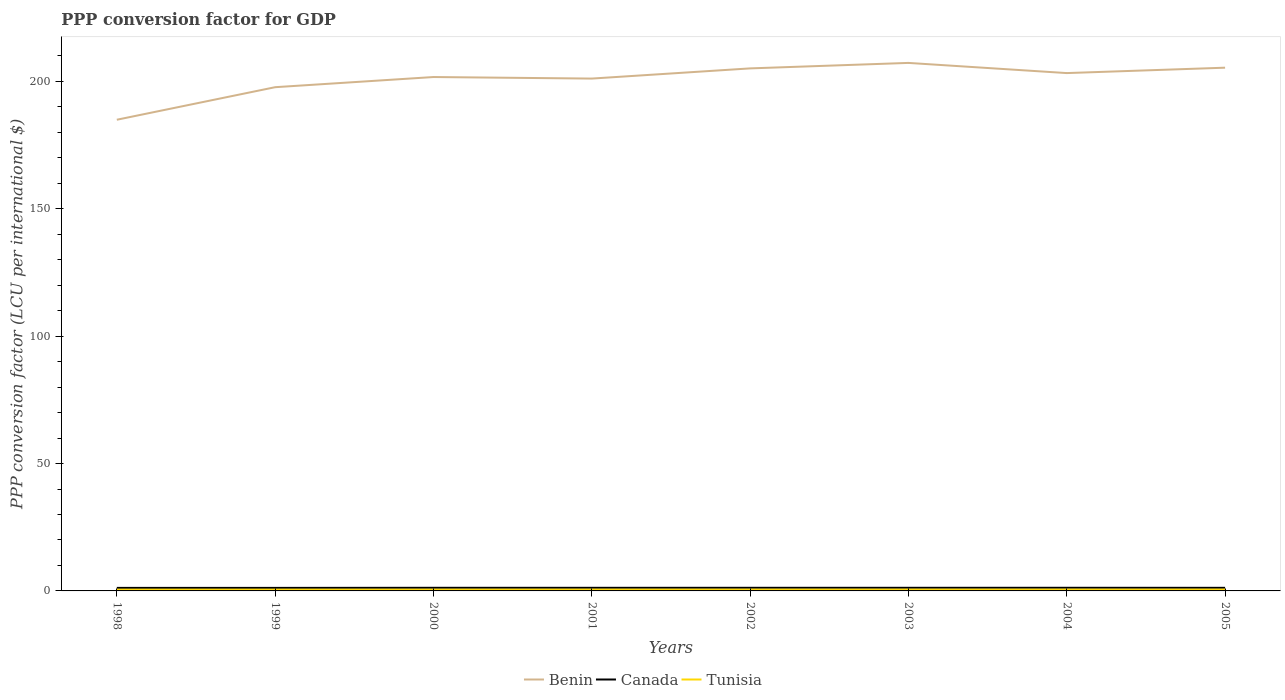How many different coloured lines are there?
Offer a very short reply. 3. Across all years, what is the maximum PPP conversion factor for GDP in Canada?
Keep it short and to the point. 1.19. What is the total PPP conversion factor for GDP in Canada in the graph?
Give a very brief answer. -0. What is the difference between the highest and the second highest PPP conversion factor for GDP in Canada?
Make the answer very short. 0.05. What is the difference between the highest and the lowest PPP conversion factor for GDP in Tunisia?
Keep it short and to the point. 5. How many lines are there?
Your answer should be compact. 3. How many years are there in the graph?
Your answer should be very brief. 8. What is the difference between two consecutive major ticks on the Y-axis?
Your response must be concise. 50. Are the values on the major ticks of Y-axis written in scientific E-notation?
Give a very brief answer. No. Does the graph contain grids?
Your answer should be very brief. No. Where does the legend appear in the graph?
Make the answer very short. Bottom center. How are the legend labels stacked?
Your answer should be very brief. Horizontal. What is the title of the graph?
Your response must be concise. PPP conversion factor for GDP. What is the label or title of the Y-axis?
Your answer should be very brief. PPP conversion factor (LCU per international $). What is the PPP conversion factor (LCU per international $) in Benin in 1998?
Your answer should be compact. 184.93. What is the PPP conversion factor (LCU per international $) in Canada in 1998?
Offer a very short reply. 1.19. What is the PPP conversion factor (LCU per international $) of Tunisia in 1998?
Your answer should be very brief. 0.49. What is the PPP conversion factor (LCU per international $) in Benin in 1999?
Keep it short and to the point. 197.71. What is the PPP conversion factor (LCU per international $) of Canada in 1999?
Make the answer very short. 1.19. What is the PPP conversion factor (LCU per international $) of Tunisia in 1999?
Offer a terse response. 0.5. What is the PPP conversion factor (LCU per international $) of Benin in 2000?
Provide a succinct answer. 201.69. What is the PPP conversion factor (LCU per international $) in Canada in 2000?
Provide a short and direct response. 1.23. What is the PPP conversion factor (LCU per international $) of Tunisia in 2000?
Your answer should be very brief. 0.5. What is the PPP conversion factor (LCU per international $) in Benin in 2001?
Offer a very short reply. 201.09. What is the PPP conversion factor (LCU per international $) of Canada in 2001?
Your answer should be very brief. 1.22. What is the PPP conversion factor (LCU per international $) in Tunisia in 2001?
Offer a very short reply. 0.51. What is the PPP conversion factor (LCU per international $) of Benin in 2002?
Ensure brevity in your answer.  205.09. What is the PPP conversion factor (LCU per international $) in Canada in 2002?
Ensure brevity in your answer.  1.23. What is the PPP conversion factor (LCU per international $) of Tunisia in 2002?
Your answer should be very brief. 0.52. What is the PPP conversion factor (LCU per international $) in Benin in 2003?
Give a very brief answer. 207.24. What is the PPP conversion factor (LCU per international $) of Canada in 2003?
Ensure brevity in your answer.  1.23. What is the PPP conversion factor (LCU per international $) in Tunisia in 2003?
Your answer should be very brief. 0.52. What is the PPP conversion factor (LCU per international $) in Benin in 2004?
Ensure brevity in your answer.  203.24. What is the PPP conversion factor (LCU per international $) in Canada in 2004?
Your answer should be very brief. 1.23. What is the PPP conversion factor (LCU per international $) of Tunisia in 2004?
Provide a succinct answer. 0.52. What is the PPP conversion factor (LCU per international $) in Benin in 2005?
Keep it short and to the point. 205.36. What is the PPP conversion factor (LCU per international $) in Canada in 2005?
Your answer should be compact. 1.21. What is the PPP conversion factor (LCU per international $) of Tunisia in 2005?
Provide a short and direct response. 0.53. Across all years, what is the maximum PPP conversion factor (LCU per international $) of Benin?
Keep it short and to the point. 207.24. Across all years, what is the maximum PPP conversion factor (LCU per international $) in Canada?
Your response must be concise. 1.23. Across all years, what is the maximum PPP conversion factor (LCU per international $) of Tunisia?
Ensure brevity in your answer.  0.53. Across all years, what is the minimum PPP conversion factor (LCU per international $) of Benin?
Your response must be concise. 184.93. Across all years, what is the minimum PPP conversion factor (LCU per international $) of Canada?
Make the answer very short. 1.19. Across all years, what is the minimum PPP conversion factor (LCU per international $) in Tunisia?
Your response must be concise. 0.49. What is the total PPP conversion factor (LCU per international $) in Benin in the graph?
Offer a very short reply. 1606.36. What is the total PPP conversion factor (LCU per international $) in Canada in the graph?
Offer a terse response. 9.73. What is the total PPP conversion factor (LCU per international $) of Tunisia in the graph?
Keep it short and to the point. 4.1. What is the difference between the PPP conversion factor (LCU per international $) in Benin in 1998 and that in 1999?
Offer a very short reply. -12.77. What is the difference between the PPP conversion factor (LCU per international $) of Canada in 1998 and that in 1999?
Provide a succinct answer. -0. What is the difference between the PPP conversion factor (LCU per international $) in Tunisia in 1998 and that in 1999?
Offer a very short reply. -0.01. What is the difference between the PPP conversion factor (LCU per international $) in Benin in 1998 and that in 2000?
Keep it short and to the point. -16.76. What is the difference between the PPP conversion factor (LCU per international $) in Canada in 1998 and that in 2000?
Give a very brief answer. -0.04. What is the difference between the PPP conversion factor (LCU per international $) of Tunisia in 1998 and that in 2000?
Your response must be concise. -0.01. What is the difference between the PPP conversion factor (LCU per international $) of Benin in 1998 and that in 2001?
Your response must be concise. -16.16. What is the difference between the PPP conversion factor (LCU per international $) of Canada in 1998 and that in 2001?
Keep it short and to the point. -0.03. What is the difference between the PPP conversion factor (LCU per international $) in Tunisia in 1998 and that in 2001?
Your answer should be compact. -0.02. What is the difference between the PPP conversion factor (LCU per international $) of Benin in 1998 and that in 2002?
Keep it short and to the point. -20.15. What is the difference between the PPP conversion factor (LCU per international $) of Canada in 1998 and that in 2002?
Offer a terse response. -0.04. What is the difference between the PPP conversion factor (LCU per international $) in Tunisia in 1998 and that in 2002?
Offer a very short reply. -0.03. What is the difference between the PPP conversion factor (LCU per international $) of Benin in 1998 and that in 2003?
Provide a short and direct response. -22.3. What is the difference between the PPP conversion factor (LCU per international $) of Canada in 1998 and that in 2003?
Make the answer very short. -0.04. What is the difference between the PPP conversion factor (LCU per international $) in Tunisia in 1998 and that in 2003?
Your answer should be compact. -0.03. What is the difference between the PPP conversion factor (LCU per international $) of Benin in 1998 and that in 2004?
Your response must be concise. -18.31. What is the difference between the PPP conversion factor (LCU per international $) in Canada in 1998 and that in 2004?
Offer a terse response. -0.05. What is the difference between the PPP conversion factor (LCU per international $) of Tunisia in 1998 and that in 2004?
Give a very brief answer. -0.03. What is the difference between the PPP conversion factor (LCU per international $) in Benin in 1998 and that in 2005?
Offer a very short reply. -20.43. What is the difference between the PPP conversion factor (LCU per international $) of Canada in 1998 and that in 2005?
Your response must be concise. -0.03. What is the difference between the PPP conversion factor (LCU per international $) in Tunisia in 1998 and that in 2005?
Your response must be concise. -0.04. What is the difference between the PPP conversion factor (LCU per international $) of Benin in 1999 and that in 2000?
Make the answer very short. -3.99. What is the difference between the PPP conversion factor (LCU per international $) in Canada in 1999 and that in 2000?
Offer a very short reply. -0.04. What is the difference between the PPP conversion factor (LCU per international $) of Tunisia in 1999 and that in 2000?
Your response must be concise. -0. What is the difference between the PPP conversion factor (LCU per international $) of Benin in 1999 and that in 2001?
Your response must be concise. -3.38. What is the difference between the PPP conversion factor (LCU per international $) of Canada in 1999 and that in 2001?
Your response must be concise. -0.03. What is the difference between the PPP conversion factor (LCU per international $) in Tunisia in 1999 and that in 2001?
Your response must be concise. -0.01. What is the difference between the PPP conversion factor (LCU per international $) in Benin in 1999 and that in 2002?
Your answer should be very brief. -7.38. What is the difference between the PPP conversion factor (LCU per international $) of Canada in 1999 and that in 2002?
Offer a very short reply. -0.04. What is the difference between the PPP conversion factor (LCU per international $) in Tunisia in 1999 and that in 2002?
Your answer should be very brief. -0.02. What is the difference between the PPP conversion factor (LCU per international $) in Benin in 1999 and that in 2003?
Your answer should be compact. -9.53. What is the difference between the PPP conversion factor (LCU per international $) in Canada in 1999 and that in 2003?
Offer a very short reply. -0.04. What is the difference between the PPP conversion factor (LCU per international $) of Tunisia in 1999 and that in 2003?
Your response must be concise. -0.02. What is the difference between the PPP conversion factor (LCU per international $) in Benin in 1999 and that in 2004?
Keep it short and to the point. -5.54. What is the difference between the PPP conversion factor (LCU per international $) in Canada in 1999 and that in 2004?
Make the answer very short. -0.04. What is the difference between the PPP conversion factor (LCU per international $) of Tunisia in 1999 and that in 2004?
Your response must be concise. -0.02. What is the difference between the PPP conversion factor (LCU per international $) of Benin in 1999 and that in 2005?
Provide a succinct answer. -7.66. What is the difference between the PPP conversion factor (LCU per international $) in Canada in 1999 and that in 2005?
Your response must be concise. -0.02. What is the difference between the PPP conversion factor (LCU per international $) of Tunisia in 1999 and that in 2005?
Keep it short and to the point. -0.03. What is the difference between the PPP conversion factor (LCU per international $) in Benin in 2000 and that in 2001?
Your answer should be compact. 0.61. What is the difference between the PPP conversion factor (LCU per international $) of Canada in 2000 and that in 2001?
Offer a very short reply. 0.01. What is the difference between the PPP conversion factor (LCU per international $) in Tunisia in 2000 and that in 2001?
Your response must be concise. -0.01. What is the difference between the PPP conversion factor (LCU per international $) of Benin in 2000 and that in 2002?
Offer a terse response. -3.39. What is the difference between the PPP conversion factor (LCU per international $) in Canada in 2000 and that in 2002?
Keep it short and to the point. -0. What is the difference between the PPP conversion factor (LCU per international $) in Tunisia in 2000 and that in 2002?
Your answer should be very brief. -0.01. What is the difference between the PPP conversion factor (LCU per international $) of Benin in 2000 and that in 2003?
Provide a short and direct response. -5.54. What is the difference between the PPP conversion factor (LCU per international $) in Canada in 2000 and that in 2003?
Offer a terse response. 0. What is the difference between the PPP conversion factor (LCU per international $) of Tunisia in 2000 and that in 2003?
Provide a succinct answer. -0.02. What is the difference between the PPP conversion factor (LCU per international $) of Benin in 2000 and that in 2004?
Keep it short and to the point. -1.55. What is the difference between the PPP conversion factor (LCU per international $) of Canada in 2000 and that in 2004?
Give a very brief answer. -0.01. What is the difference between the PPP conversion factor (LCU per international $) of Tunisia in 2000 and that in 2004?
Your answer should be compact. -0.02. What is the difference between the PPP conversion factor (LCU per international $) in Benin in 2000 and that in 2005?
Offer a terse response. -3.67. What is the difference between the PPP conversion factor (LCU per international $) of Canada in 2000 and that in 2005?
Offer a very short reply. 0.01. What is the difference between the PPP conversion factor (LCU per international $) in Tunisia in 2000 and that in 2005?
Offer a very short reply. -0.02. What is the difference between the PPP conversion factor (LCU per international $) in Benin in 2001 and that in 2002?
Give a very brief answer. -4. What is the difference between the PPP conversion factor (LCU per international $) of Canada in 2001 and that in 2002?
Your answer should be compact. -0.01. What is the difference between the PPP conversion factor (LCU per international $) in Tunisia in 2001 and that in 2002?
Your response must be concise. -0. What is the difference between the PPP conversion factor (LCU per international $) of Benin in 2001 and that in 2003?
Keep it short and to the point. -6.15. What is the difference between the PPP conversion factor (LCU per international $) of Canada in 2001 and that in 2003?
Provide a succinct answer. -0.01. What is the difference between the PPP conversion factor (LCU per international $) in Tunisia in 2001 and that in 2003?
Offer a very short reply. -0.01. What is the difference between the PPP conversion factor (LCU per international $) of Benin in 2001 and that in 2004?
Give a very brief answer. -2.16. What is the difference between the PPP conversion factor (LCU per international $) in Canada in 2001 and that in 2004?
Ensure brevity in your answer.  -0.01. What is the difference between the PPP conversion factor (LCU per international $) in Tunisia in 2001 and that in 2004?
Your answer should be compact. -0.01. What is the difference between the PPP conversion factor (LCU per international $) of Benin in 2001 and that in 2005?
Offer a very short reply. -4.27. What is the difference between the PPP conversion factor (LCU per international $) of Canada in 2001 and that in 2005?
Give a very brief answer. 0.01. What is the difference between the PPP conversion factor (LCU per international $) of Tunisia in 2001 and that in 2005?
Offer a very short reply. -0.02. What is the difference between the PPP conversion factor (LCU per international $) in Benin in 2002 and that in 2003?
Ensure brevity in your answer.  -2.15. What is the difference between the PPP conversion factor (LCU per international $) in Canada in 2002 and that in 2003?
Offer a terse response. 0. What is the difference between the PPP conversion factor (LCU per international $) of Tunisia in 2002 and that in 2003?
Offer a terse response. -0. What is the difference between the PPP conversion factor (LCU per international $) of Benin in 2002 and that in 2004?
Give a very brief answer. 1.84. What is the difference between the PPP conversion factor (LCU per international $) in Canada in 2002 and that in 2004?
Provide a succinct answer. -0. What is the difference between the PPP conversion factor (LCU per international $) in Tunisia in 2002 and that in 2004?
Provide a short and direct response. -0.01. What is the difference between the PPP conversion factor (LCU per international $) of Benin in 2002 and that in 2005?
Ensure brevity in your answer.  -0.28. What is the difference between the PPP conversion factor (LCU per international $) in Canada in 2002 and that in 2005?
Keep it short and to the point. 0.02. What is the difference between the PPP conversion factor (LCU per international $) in Tunisia in 2002 and that in 2005?
Give a very brief answer. -0.01. What is the difference between the PPP conversion factor (LCU per international $) of Benin in 2003 and that in 2004?
Give a very brief answer. 3.99. What is the difference between the PPP conversion factor (LCU per international $) of Canada in 2003 and that in 2004?
Ensure brevity in your answer.  -0.01. What is the difference between the PPP conversion factor (LCU per international $) in Tunisia in 2003 and that in 2004?
Provide a succinct answer. -0. What is the difference between the PPP conversion factor (LCU per international $) of Benin in 2003 and that in 2005?
Offer a terse response. 1.87. What is the difference between the PPP conversion factor (LCU per international $) in Canada in 2003 and that in 2005?
Give a very brief answer. 0.01. What is the difference between the PPP conversion factor (LCU per international $) in Tunisia in 2003 and that in 2005?
Give a very brief answer. -0.01. What is the difference between the PPP conversion factor (LCU per international $) of Benin in 2004 and that in 2005?
Provide a short and direct response. -2.12. What is the difference between the PPP conversion factor (LCU per international $) of Canada in 2004 and that in 2005?
Provide a succinct answer. 0.02. What is the difference between the PPP conversion factor (LCU per international $) in Tunisia in 2004 and that in 2005?
Provide a short and direct response. -0. What is the difference between the PPP conversion factor (LCU per international $) in Benin in 1998 and the PPP conversion factor (LCU per international $) in Canada in 1999?
Give a very brief answer. 183.74. What is the difference between the PPP conversion factor (LCU per international $) of Benin in 1998 and the PPP conversion factor (LCU per international $) of Tunisia in 1999?
Keep it short and to the point. 184.43. What is the difference between the PPP conversion factor (LCU per international $) in Canada in 1998 and the PPP conversion factor (LCU per international $) in Tunisia in 1999?
Provide a short and direct response. 0.69. What is the difference between the PPP conversion factor (LCU per international $) in Benin in 1998 and the PPP conversion factor (LCU per international $) in Canada in 2000?
Your response must be concise. 183.71. What is the difference between the PPP conversion factor (LCU per international $) of Benin in 1998 and the PPP conversion factor (LCU per international $) of Tunisia in 2000?
Make the answer very short. 184.43. What is the difference between the PPP conversion factor (LCU per international $) of Canada in 1998 and the PPP conversion factor (LCU per international $) of Tunisia in 2000?
Offer a terse response. 0.68. What is the difference between the PPP conversion factor (LCU per international $) of Benin in 1998 and the PPP conversion factor (LCU per international $) of Canada in 2001?
Keep it short and to the point. 183.71. What is the difference between the PPP conversion factor (LCU per international $) of Benin in 1998 and the PPP conversion factor (LCU per international $) of Tunisia in 2001?
Your answer should be compact. 184.42. What is the difference between the PPP conversion factor (LCU per international $) in Canada in 1998 and the PPP conversion factor (LCU per international $) in Tunisia in 2001?
Provide a succinct answer. 0.67. What is the difference between the PPP conversion factor (LCU per international $) in Benin in 1998 and the PPP conversion factor (LCU per international $) in Canada in 2002?
Provide a short and direct response. 183.7. What is the difference between the PPP conversion factor (LCU per international $) in Benin in 1998 and the PPP conversion factor (LCU per international $) in Tunisia in 2002?
Provide a succinct answer. 184.42. What is the difference between the PPP conversion factor (LCU per international $) in Canada in 1998 and the PPP conversion factor (LCU per international $) in Tunisia in 2002?
Provide a succinct answer. 0.67. What is the difference between the PPP conversion factor (LCU per international $) of Benin in 1998 and the PPP conversion factor (LCU per international $) of Canada in 2003?
Provide a short and direct response. 183.71. What is the difference between the PPP conversion factor (LCU per international $) in Benin in 1998 and the PPP conversion factor (LCU per international $) in Tunisia in 2003?
Ensure brevity in your answer.  184.41. What is the difference between the PPP conversion factor (LCU per international $) in Canada in 1998 and the PPP conversion factor (LCU per international $) in Tunisia in 2003?
Ensure brevity in your answer.  0.67. What is the difference between the PPP conversion factor (LCU per international $) in Benin in 1998 and the PPP conversion factor (LCU per international $) in Canada in 2004?
Your answer should be very brief. 183.7. What is the difference between the PPP conversion factor (LCU per international $) of Benin in 1998 and the PPP conversion factor (LCU per international $) of Tunisia in 2004?
Offer a very short reply. 184.41. What is the difference between the PPP conversion factor (LCU per international $) in Canada in 1998 and the PPP conversion factor (LCU per international $) in Tunisia in 2004?
Keep it short and to the point. 0.66. What is the difference between the PPP conversion factor (LCU per international $) in Benin in 1998 and the PPP conversion factor (LCU per international $) in Canada in 2005?
Give a very brief answer. 183.72. What is the difference between the PPP conversion factor (LCU per international $) of Benin in 1998 and the PPP conversion factor (LCU per international $) of Tunisia in 2005?
Provide a succinct answer. 184.41. What is the difference between the PPP conversion factor (LCU per international $) in Canada in 1998 and the PPP conversion factor (LCU per international $) in Tunisia in 2005?
Offer a very short reply. 0.66. What is the difference between the PPP conversion factor (LCU per international $) in Benin in 1999 and the PPP conversion factor (LCU per international $) in Canada in 2000?
Your answer should be compact. 196.48. What is the difference between the PPP conversion factor (LCU per international $) in Benin in 1999 and the PPP conversion factor (LCU per international $) in Tunisia in 2000?
Your answer should be very brief. 197.2. What is the difference between the PPP conversion factor (LCU per international $) in Canada in 1999 and the PPP conversion factor (LCU per international $) in Tunisia in 2000?
Keep it short and to the point. 0.69. What is the difference between the PPP conversion factor (LCU per international $) in Benin in 1999 and the PPP conversion factor (LCU per international $) in Canada in 2001?
Provide a short and direct response. 196.49. What is the difference between the PPP conversion factor (LCU per international $) of Benin in 1999 and the PPP conversion factor (LCU per international $) of Tunisia in 2001?
Provide a short and direct response. 197.19. What is the difference between the PPP conversion factor (LCU per international $) of Canada in 1999 and the PPP conversion factor (LCU per international $) of Tunisia in 2001?
Give a very brief answer. 0.68. What is the difference between the PPP conversion factor (LCU per international $) of Benin in 1999 and the PPP conversion factor (LCU per international $) of Canada in 2002?
Ensure brevity in your answer.  196.48. What is the difference between the PPP conversion factor (LCU per international $) of Benin in 1999 and the PPP conversion factor (LCU per international $) of Tunisia in 2002?
Provide a succinct answer. 197.19. What is the difference between the PPP conversion factor (LCU per international $) of Canada in 1999 and the PPP conversion factor (LCU per international $) of Tunisia in 2002?
Give a very brief answer. 0.67. What is the difference between the PPP conversion factor (LCU per international $) of Benin in 1999 and the PPP conversion factor (LCU per international $) of Canada in 2003?
Offer a terse response. 196.48. What is the difference between the PPP conversion factor (LCU per international $) of Benin in 1999 and the PPP conversion factor (LCU per international $) of Tunisia in 2003?
Make the answer very short. 197.19. What is the difference between the PPP conversion factor (LCU per international $) of Canada in 1999 and the PPP conversion factor (LCU per international $) of Tunisia in 2003?
Ensure brevity in your answer.  0.67. What is the difference between the PPP conversion factor (LCU per international $) in Benin in 1999 and the PPP conversion factor (LCU per international $) in Canada in 2004?
Provide a short and direct response. 196.47. What is the difference between the PPP conversion factor (LCU per international $) of Benin in 1999 and the PPP conversion factor (LCU per international $) of Tunisia in 2004?
Your answer should be very brief. 197.18. What is the difference between the PPP conversion factor (LCU per international $) in Canada in 1999 and the PPP conversion factor (LCU per international $) in Tunisia in 2004?
Give a very brief answer. 0.67. What is the difference between the PPP conversion factor (LCU per international $) in Benin in 1999 and the PPP conversion factor (LCU per international $) in Canada in 2005?
Provide a short and direct response. 196.49. What is the difference between the PPP conversion factor (LCU per international $) in Benin in 1999 and the PPP conversion factor (LCU per international $) in Tunisia in 2005?
Your response must be concise. 197.18. What is the difference between the PPP conversion factor (LCU per international $) in Canada in 1999 and the PPP conversion factor (LCU per international $) in Tunisia in 2005?
Offer a very short reply. 0.66. What is the difference between the PPP conversion factor (LCU per international $) in Benin in 2000 and the PPP conversion factor (LCU per international $) in Canada in 2001?
Give a very brief answer. 200.47. What is the difference between the PPP conversion factor (LCU per international $) in Benin in 2000 and the PPP conversion factor (LCU per international $) in Tunisia in 2001?
Provide a succinct answer. 201.18. What is the difference between the PPP conversion factor (LCU per international $) of Canada in 2000 and the PPP conversion factor (LCU per international $) of Tunisia in 2001?
Provide a short and direct response. 0.71. What is the difference between the PPP conversion factor (LCU per international $) of Benin in 2000 and the PPP conversion factor (LCU per international $) of Canada in 2002?
Ensure brevity in your answer.  200.47. What is the difference between the PPP conversion factor (LCU per international $) of Benin in 2000 and the PPP conversion factor (LCU per international $) of Tunisia in 2002?
Your answer should be compact. 201.18. What is the difference between the PPP conversion factor (LCU per international $) of Canada in 2000 and the PPP conversion factor (LCU per international $) of Tunisia in 2002?
Your response must be concise. 0.71. What is the difference between the PPP conversion factor (LCU per international $) in Benin in 2000 and the PPP conversion factor (LCU per international $) in Canada in 2003?
Ensure brevity in your answer.  200.47. What is the difference between the PPP conversion factor (LCU per international $) of Benin in 2000 and the PPP conversion factor (LCU per international $) of Tunisia in 2003?
Your answer should be very brief. 201.17. What is the difference between the PPP conversion factor (LCU per international $) in Canada in 2000 and the PPP conversion factor (LCU per international $) in Tunisia in 2003?
Provide a succinct answer. 0.71. What is the difference between the PPP conversion factor (LCU per international $) in Benin in 2000 and the PPP conversion factor (LCU per international $) in Canada in 2004?
Make the answer very short. 200.46. What is the difference between the PPP conversion factor (LCU per international $) in Benin in 2000 and the PPP conversion factor (LCU per international $) in Tunisia in 2004?
Make the answer very short. 201.17. What is the difference between the PPP conversion factor (LCU per international $) of Canada in 2000 and the PPP conversion factor (LCU per international $) of Tunisia in 2004?
Your answer should be very brief. 0.7. What is the difference between the PPP conversion factor (LCU per international $) of Benin in 2000 and the PPP conversion factor (LCU per international $) of Canada in 2005?
Your answer should be compact. 200.48. What is the difference between the PPP conversion factor (LCU per international $) in Benin in 2000 and the PPP conversion factor (LCU per international $) in Tunisia in 2005?
Provide a succinct answer. 201.17. What is the difference between the PPP conversion factor (LCU per international $) in Canada in 2000 and the PPP conversion factor (LCU per international $) in Tunisia in 2005?
Offer a very short reply. 0.7. What is the difference between the PPP conversion factor (LCU per international $) of Benin in 2001 and the PPP conversion factor (LCU per international $) of Canada in 2002?
Provide a succinct answer. 199.86. What is the difference between the PPP conversion factor (LCU per international $) in Benin in 2001 and the PPP conversion factor (LCU per international $) in Tunisia in 2002?
Provide a succinct answer. 200.57. What is the difference between the PPP conversion factor (LCU per international $) of Canada in 2001 and the PPP conversion factor (LCU per international $) of Tunisia in 2002?
Keep it short and to the point. 0.7. What is the difference between the PPP conversion factor (LCU per international $) of Benin in 2001 and the PPP conversion factor (LCU per international $) of Canada in 2003?
Give a very brief answer. 199.86. What is the difference between the PPP conversion factor (LCU per international $) in Benin in 2001 and the PPP conversion factor (LCU per international $) in Tunisia in 2003?
Make the answer very short. 200.57. What is the difference between the PPP conversion factor (LCU per international $) of Canada in 2001 and the PPP conversion factor (LCU per international $) of Tunisia in 2003?
Ensure brevity in your answer.  0.7. What is the difference between the PPP conversion factor (LCU per international $) in Benin in 2001 and the PPP conversion factor (LCU per international $) in Canada in 2004?
Make the answer very short. 199.86. What is the difference between the PPP conversion factor (LCU per international $) of Benin in 2001 and the PPP conversion factor (LCU per international $) of Tunisia in 2004?
Provide a succinct answer. 200.57. What is the difference between the PPP conversion factor (LCU per international $) of Canada in 2001 and the PPP conversion factor (LCU per international $) of Tunisia in 2004?
Keep it short and to the point. 0.7. What is the difference between the PPP conversion factor (LCU per international $) of Benin in 2001 and the PPP conversion factor (LCU per international $) of Canada in 2005?
Your answer should be very brief. 199.88. What is the difference between the PPP conversion factor (LCU per international $) of Benin in 2001 and the PPP conversion factor (LCU per international $) of Tunisia in 2005?
Give a very brief answer. 200.56. What is the difference between the PPP conversion factor (LCU per international $) in Canada in 2001 and the PPP conversion factor (LCU per international $) in Tunisia in 2005?
Offer a very short reply. 0.69. What is the difference between the PPP conversion factor (LCU per international $) in Benin in 2002 and the PPP conversion factor (LCU per international $) in Canada in 2003?
Make the answer very short. 203.86. What is the difference between the PPP conversion factor (LCU per international $) in Benin in 2002 and the PPP conversion factor (LCU per international $) in Tunisia in 2003?
Make the answer very short. 204.57. What is the difference between the PPP conversion factor (LCU per international $) in Canada in 2002 and the PPP conversion factor (LCU per international $) in Tunisia in 2003?
Give a very brief answer. 0.71. What is the difference between the PPP conversion factor (LCU per international $) of Benin in 2002 and the PPP conversion factor (LCU per international $) of Canada in 2004?
Provide a succinct answer. 203.85. What is the difference between the PPP conversion factor (LCU per international $) of Benin in 2002 and the PPP conversion factor (LCU per international $) of Tunisia in 2004?
Make the answer very short. 204.56. What is the difference between the PPP conversion factor (LCU per international $) in Canada in 2002 and the PPP conversion factor (LCU per international $) in Tunisia in 2004?
Your answer should be compact. 0.71. What is the difference between the PPP conversion factor (LCU per international $) in Benin in 2002 and the PPP conversion factor (LCU per international $) in Canada in 2005?
Offer a terse response. 203.87. What is the difference between the PPP conversion factor (LCU per international $) of Benin in 2002 and the PPP conversion factor (LCU per international $) of Tunisia in 2005?
Provide a short and direct response. 204.56. What is the difference between the PPP conversion factor (LCU per international $) of Canada in 2002 and the PPP conversion factor (LCU per international $) of Tunisia in 2005?
Keep it short and to the point. 0.7. What is the difference between the PPP conversion factor (LCU per international $) in Benin in 2003 and the PPP conversion factor (LCU per international $) in Canada in 2004?
Offer a very short reply. 206. What is the difference between the PPP conversion factor (LCU per international $) in Benin in 2003 and the PPP conversion factor (LCU per international $) in Tunisia in 2004?
Offer a terse response. 206.71. What is the difference between the PPP conversion factor (LCU per international $) of Canada in 2003 and the PPP conversion factor (LCU per international $) of Tunisia in 2004?
Provide a short and direct response. 0.7. What is the difference between the PPP conversion factor (LCU per international $) in Benin in 2003 and the PPP conversion factor (LCU per international $) in Canada in 2005?
Your answer should be compact. 206.02. What is the difference between the PPP conversion factor (LCU per international $) in Benin in 2003 and the PPP conversion factor (LCU per international $) in Tunisia in 2005?
Provide a succinct answer. 206.71. What is the difference between the PPP conversion factor (LCU per international $) of Canada in 2003 and the PPP conversion factor (LCU per international $) of Tunisia in 2005?
Offer a very short reply. 0.7. What is the difference between the PPP conversion factor (LCU per international $) of Benin in 2004 and the PPP conversion factor (LCU per international $) of Canada in 2005?
Your answer should be compact. 202.03. What is the difference between the PPP conversion factor (LCU per international $) in Benin in 2004 and the PPP conversion factor (LCU per international $) in Tunisia in 2005?
Give a very brief answer. 202.72. What is the difference between the PPP conversion factor (LCU per international $) in Canada in 2004 and the PPP conversion factor (LCU per international $) in Tunisia in 2005?
Your answer should be compact. 0.7. What is the average PPP conversion factor (LCU per international $) in Benin per year?
Your answer should be compact. 200.79. What is the average PPP conversion factor (LCU per international $) in Canada per year?
Your answer should be compact. 1.22. What is the average PPP conversion factor (LCU per international $) in Tunisia per year?
Your answer should be compact. 0.51. In the year 1998, what is the difference between the PPP conversion factor (LCU per international $) of Benin and PPP conversion factor (LCU per international $) of Canada?
Give a very brief answer. 183.75. In the year 1998, what is the difference between the PPP conversion factor (LCU per international $) in Benin and PPP conversion factor (LCU per international $) in Tunisia?
Your answer should be compact. 184.44. In the year 1998, what is the difference between the PPP conversion factor (LCU per international $) in Canada and PPP conversion factor (LCU per international $) in Tunisia?
Your answer should be very brief. 0.7. In the year 1999, what is the difference between the PPP conversion factor (LCU per international $) in Benin and PPP conversion factor (LCU per international $) in Canada?
Your answer should be compact. 196.52. In the year 1999, what is the difference between the PPP conversion factor (LCU per international $) in Benin and PPP conversion factor (LCU per international $) in Tunisia?
Provide a succinct answer. 197.21. In the year 1999, what is the difference between the PPP conversion factor (LCU per international $) in Canada and PPP conversion factor (LCU per international $) in Tunisia?
Offer a terse response. 0.69. In the year 2000, what is the difference between the PPP conversion factor (LCU per international $) of Benin and PPP conversion factor (LCU per international $) of Canada?
Offer a very short reply. 200.47. In the year 2000, what is the difference between the PPP conversion factor (LCU per international $) of Benin and PPP conversion factor (LCU per international $) of Tunisia?
Your answer should be compact. 201.19. In the year 2000, what is the difference between the PPP conversion factor (LCU per international $) of Canada and PPP conversion factor (LCU per international $) of Tunisia?
Offer a very short reply. 0.72. In the year 2001, what is the difference between the PPP conversion factor (LCU per international $) of Benin and PPP conversion factor (LCU per international $) of Canada?
Keep it short and to the point. 199.87. In the year 2001, what is the difference between the PPP conversion factor (LCU per international $) of Benin and PPP conversion factor (LCU per international $) of Tunisia?
Your answer should be very brief. 200.58. In the year 2001, what is the difference between the PPP conversion factor (LCU per international $) in Canada and PPP conversion factor (LCU per international $) in Tunisia?
Your answer should be very brief. 0.71. In the year 2002, what is the difference between the PPP conversion factor (LCU per international $) of Benin and PPP conversion factor (LCU per international $) of Canada?
Your answer should be compact. 203.86. In the year 2002, what is the difference between the PPP conversion factor (LCU per international $) of Benin and PPP conversion factor (LCU per international $) of Tunisia?
Offer a terse response. 204.57. In the year 2002, what is the difference between the PPP conversion factor (LCU per international $) of Canada and PPP conversion factor (LCU per international $) of Tunisia?
Ensure brevity in your answer.  0.71. In the year 2003, what is the difference between the PPP conversion factor (LCU per international $) in Benin and PPP conversion factor (LCU per international $) in Canada?
Provide a short and direct response. 206.01. In the year 2003, what is the difference between the PPP conversion factor (LCU per international $) of Benin and PPP conversion factor (LCU per international $) of Tunisia?
Provide a short and direct response. 206.72. In the year 2003, what is the difference between the PPP conversion factor (LCU per international $) in Canada and PPP conversion factor (LCU per international $) in Tunisia?
Your answer should be compact. 0.71. In the year 2004, what is the difference between the PPP conversion factor (LCU per international $) in Benin and PPP conversion factor (LCU per international $) in Canada?
Make the answer very short. 202.01. In the year 2004, what is the difference between the PPP conversion factor (LCU per international $) in Benin and PPP conversion factor (LCU per international $) in Tunisia?
Make the answer very short. 202.72. In the year 2004, what is the difference between the PPP conversion factor (LCU per international $) in Canada and PPP conversion factor (LCU per international $) in Tunisia?
Make the answer very short. 0.71. In the year 2005, what is the difference between the PPP conversion factor (LCU per international $) of Benin and PPP conversion factor (LCU per international $) of Canada?
Give a very brief answer. 204.15. In the year 2005, what is the difference between the PPP conversion factor (LCU per international $) of Benin and PPP conversion factor (LCU per international $) of Tunisia?
Keep it short and to the point. 204.84. In the year 2005, what is the difference between the PPP conversion factor (LCU per international $) in Canada and PPP conversion factor (LCU per international $) in Tunisia?
Provide a short and direct response. 0.69. What is the ratio of the PPP conversion factor (LCU per international $) in Benin in 1998 to that in 1999?
Your answer should be very brief. 0.94. What is the ratio of the PPP conversion factor (LCU per international $) in Tunisia in 1998 to that in 1999?
Ensure brevity in your answer.  0.98. What is the ratio of the PPP conversion factor (LCU per international $) in Benin in 1998 to that in 2000?
Give a very brief answer. 0.92. What is the ratio of the PPP conversion factor (LCU per international $) in Canada in 1998 to that in 2000?
Make the answer very short. 0.97. What is the ratio of the PPP conversion factor (LCU per international $) in Tunisia in 1998 to that in 2000?
Provide a succinct answer. 0.97. What is the ratio of the PPP conversion factor (LCU per international $) of Benin in 1998 to that in 2001?
Keep it short and to the point. 0.92. What is the ratio of the PPP conversion factor (LCU per international $) of Canada in 1998 to that in 2001?
Keep it short and to the point. 0.97. What is the ratio of the PPP conversion factor (LCU per international $) in Tunisia in 1998 to that in 2001?
Ensure brevity in your answer.  0.96. What is the ratio of the PPP conversion factor (LCU per international $) of Benin in 1998 to that in 2002?
Make the answer very short. 0.9. What is the ratio of the PPP conversion factor (LCU per international $) of Canada in 1998 to that in 2002?
Offer a terse response. 0.97. What is the ratio of the PPP conversion factor (LCU per international $) of Tunisia in 1998 to that in 2002?
Ensure brevity in your answer.  0.95. What is the ratio of the PPP conversion factor (LCU per international $) in Benin in 1998 to that in 2003?
Offer a very short reply. 0.89. What is the ratio of the PPP conversion factor (LCU per international $) in Canada in 1998 to that in 2003?
Make the answer very short. 0.97. What is the ratio of the PPP conversion factor (LCU per international $) in Tunisia in 1998 to that in 2003?
Offer a terse response. 0.94. What is the ratio of the PPP conversion factor (LCU per international $) in Benin in 1998 to that in 2004?
Provide a succinct answer. 0.91. What is the ratio of the PPP conversion factor (LCU per international $) of Canada in 1998 to that in 2004?
Your answer should be very brief. 0.96. What is the ratio of the PPP conversion factor (LCU per international $) in Tunisia in 1998 to that in 2004?
Offer a very short reply. 0.94. What is the ratio of the PPP conversion factor (LCU per international $) of Benin in 1998 to that in 2005?
Your answer should be very brief. 0.9. What is the ratio of the PPP conversion factor (LCU per international $) of Canada in 1998 to that in 2005?
Your response must be concise. 0.98. What is the ratio of the PPP conversion factor (LCU per international $) of Tunisia in 1998 to that in 2005?
Offer a terse response. 0.93. What is the ratio of the PPP conversion factor (LCU per international $) of Benin in 1999 to that in 2000?
Provide a short and direct response. 0.98. What is the ratio of the PPP conversion factor (LCU per international $) in Canada in 1999 to that in 2000?
Offer a very short reply. 0.97. What is the ratio of the PPP conversion factor (LCU per international $) of Tunisia in 1999 to that in 2000?
Provide a short and direct response. 0.99. What is the ratio of the PPP conversion factor (LCU per international $) of Benin in 1999 to that in 2001?
Offer a terse response. 0.98. What is the ratio of the PPP conversion factor (LCU per international $) of Canada in 1999 to that in 2001?
Keep it short and to the point. 0.98. What is the ratio of the PPP conversion factor (LCU per international $) of Tunisia in 1999 to that in 2001?
Your answer should be very brief. 0.97. What is the ratio of the PPP conversion factor (LCU per international $) in Benin in 1999 to that in 2002?
Offer a terse response. 0.96. What is the ratio of the PPP conversion factor (LCU per international $) of Canada in 1999 to that in 2002?
Ensure brevity in your answer.  0.97. What is the ratio of the PPP conversion factor (LCU per international $) in Tunisia in 1999 to that in 2002?
Provide a succinct answer. 0.97. What is the ratio of the PPP conversion factor (LCU per international $) in Benin in 1999 to that in 2003?
Ensure brevity in your answer.  0.95. What is the ratio of the PPP conversion factor (LCU per international $) of Benin in 1999 to that in 2004?
Give a very brief answer. 0.97. What is the ratio of the PPP conversion factor (LCU per international $) in Tunisia in 1999 to that in 2004?
Offer a very short reply. 0.96. What is the ratio of the PPP conversion factor (LCU per international $) of Benin in 1999 to that in 2005?
Keep it short and to the point. 0.96. What is the ratio of the PPP conversion factor (LCU per international $) of Canada in 1999 to that in 2005?
Provide a short and direct response. 0.98. What is the ratio of the PPP conversion factor (LCU per international $) in Tunisia in 1999 to that in 2005?
Make the answer very short. 0.95. What is the ratio of the PPP conversion factor (LCU per international $) of Tunisia in 2000 to that in 2001?
Make the answer very short. 0.98. What is the ratio of the PPP conversion factor (LCU per international $) of Benin in 2000 to that in 2002?
Your response must be concise. 0.98. What is the ratio of the PPP conversion factor (LCU per international $) in Canada in 2000 to that in 2002?
Your answer should be compact. 1. What is the ratio of the PPP conversion factor (LCU per international $) in Tunisia in 2000 to that in 2002?
Ensure brevity in your answer.  0.98. What is the ratio of the PPP conversion factor (LCU per international $) in Benin in 2000 to that in 2003?
Keep it short and to the point. 0.97. What is the ratio of the PPP conversion factor (LCU per international $) of Canada in 2000 to that in 2003?
Your answer should be compact. 1. What is the ratio of the PPP conversion factor (LCU per international $) in Tunisia in 2000 to that in 2003?
Make the answer very short. 0.97. What is the ratio of the PPP conversion factor (LCU per international $) of Benin in 2000 to that in 2004?
Offer a very short reply. 0.99. What is the ratio of the PPP conversion factor (LCU per international $) of Canada in 2000 to that in 2004?
Your response must be concise. 1. What is the ratio of the PPP conversion factor (LCU per international $) in Tunisia in 2000 to that in 2004?
Your answer should be very brief. 0.96. What is the ratio of the PPP conversion factor (LCU per international $) in Benin in 2000 to that in 2005?
Keep it short and to the point. 0.98. What is the ratio of the PPP conversion factor (LCU per international $) of Canada in 2000 to that in 2005?
Make the answer very short. 1.01. What is the ratio of the PPP conversion factor (LCU per international $) in Tunisia in 2000 to that in 2005?
Your response must be concise. 0.96. What is the ratio of the PPP conversion factor (LCU per international $) in Benin in 2001 to that in 2002?
Your answer should be compact. 0.98. What is the ratio of the PPP conversion factor (LCU per international $) in Benin in 2001 to that in 2003?
Your response must be concise. 0.97. What is the ratio of the PPP conversion factor (LCU per international $) of Canada in 2001 to that in 2003?
Provide a succinct answer. 0.99. What is the ratio of the PPP conversion factor (LCU per international $) of Canada in 2001 to that in 2004?
Give a very brief answer. 0.99. What is the ratio of the PPP conversion factor (LCU per international $) of Tunisia in 2001 to that in 2004?
Your answer should be very brief. 0.98. What is the ratio of the PPP conversion factor (LCU per international $) in Benin in 2001 to that in 2005?
Offer a terse response. 0.98. What is the ratio of the PPP conversion factor (LCU per international $) in Canada in 2001 to that in 2005?
Provide a short and direct response. 1. What is the ratio of the PPP conversion factor (LCU per international $) in Tunisia in 2001 to that in 2005?
Provide a short and direct response. 0.97. What is the ratio of the PPP conversion factor (LCU per international $) in Benin in 2002 to that in 2004?
Keep it short and to the point. 1.01. What is the ratio of the PPP conversion factor (LCU per international $) of Tunisia in 2002 to that in 2004?
Your answer should be very brief. 0.99. What is the ratio of the PPP conversion factor (LCU per international $) in Canada in 2002 to that in 2005?
Your answer should be very brief. 1.01. What is the ratio of the PPP conversion factor (LCU per international $) in Tunisia in 2002 to that in 2005?
Offer a very short reply. 0.98. What is the ratio of the PPP conversion factor (LCU per international $) in Benin in 2003 to that in 2004?
Offer a terse response. 1.02. What is the ratio of the PPP conversion factor (LCU per international $) in Canada in 2003 to that in 2004?
Offer a terse response. 0.99. What is the ratio of the PPP conversion factor (LCU per international $) of Tunisia in 2003 to that in 2004?
Provide a short and direct response. 0.99. What is the ratio of the PPP conversion factor (LCU per international $) of Benin in 2003 to that in 2005?
Offer a very short reply. 1.01. What is the ratio of the PPP conversion factor (LCU per international $) in Canada in 2003 to that in 2005?
Offer a very short reply. 1.01. What is the ratio of the PPP conversion factor (LCU per international $) of Benin in 2004 to that in 2005?
Give a very brief answer. 0.99. What is the ratio of the PPP conversion factor (LCU per international $) in Canada in 2004 to that in 2005?
Ensure brevity in your answer.  1.02. What is the difference between the highest and the second highest PPP conversion factor (LCU per international $) of Benin?
Make the answer very short. 1.87. What is the difference between the highest and the second highest PPP conversion factor (LCU per international $) in Canada?
Provide a succinct answer. 0. What is the difference between the highest and the second highest PPP conversion factor (LCU per international $) of Tunisia?
Offer a very short reply. 0. What is the difference between the highest and the lowest PPP conversion factor (LCU per international $) of Benin?
Offer a very short reply. 22.3. What is the difference between the highest and the lowest PPP conversion factor (LCU per international $) of Canada?
Your answer should be compact. 0.05. What is the difference between the highest and the lowest PPP conversion factor (LCU per international $) in Tunisia?
Your answer should be compact. 0.04. 